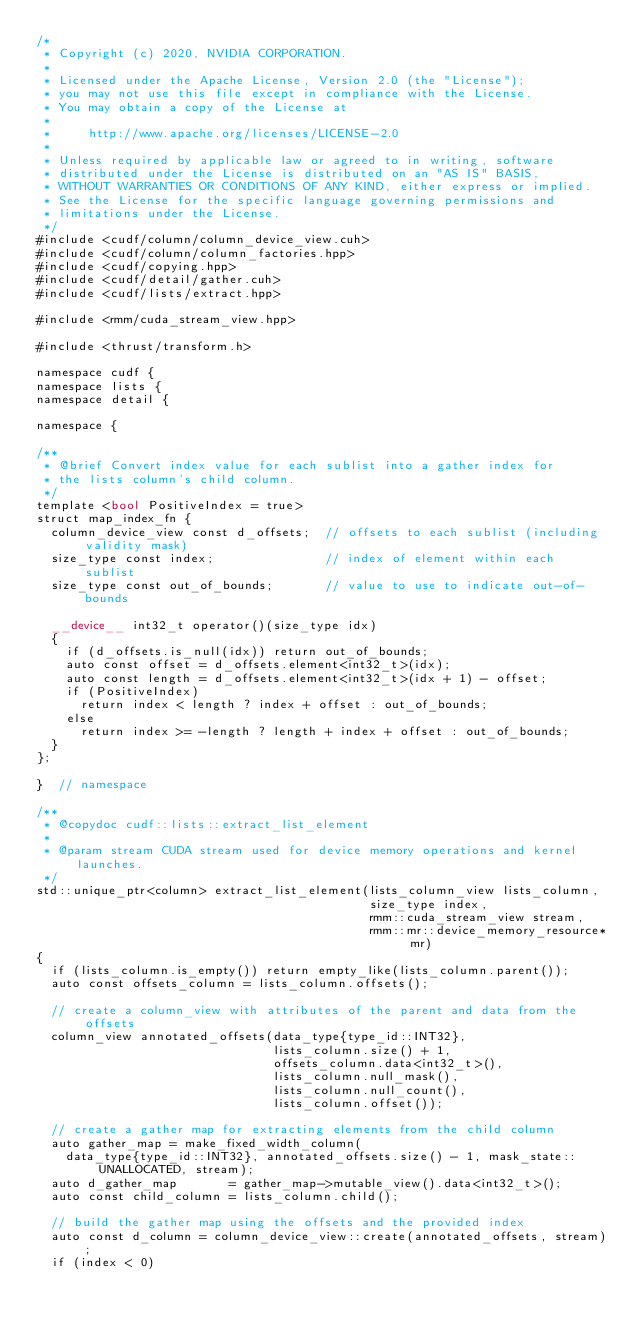<code> <loc_0><loc_0><loc_500><loc_500><_Cuda_>/*
 * Copyright (c) 2020, NVIDIA CORPORATION.
 *
 * Licensed under the Apache License, Version 2.0 (the "License");
 * you may not use this file except in compliance with the License.
 * You may obtain a copy of the License at
 *
 *     http://www.apache.org/licenses/LICENSE-2.0
 *
 * Unless required by applicable law or agreed to in writing, software
 * distributed under the License is distributed on an "AS IS" BASIS,
 * WITHOUT WARRANTIES OR CONDITIONS OF ANY KIND, either express or implied.
 * See the License for the specific language governing permissions and
 * limitations under the License.
 */
#include <cudf/column/column_device_view.cuh>
#include <cudf/column/column_factories.hpp>
#include <cudf/copying.hpp>
#include <cudf/detail/gather.cuh>
#include <cudf/lists/extract.hpp>

#include <rmm/cuda_stream_view.hpp>

#include <thrust/transform.h>

namespace cudf {
namespace lists {
namespace detail {

namespace {

/**
 * @brief Convert index value for each sublist into a gather index for
 * the lists column's child column.
 */
template <bool PositiveIndex = true>
struct map_index_fn {
  column_device_view const d_offsets;  // offsets to each sublist (including validity mask)
  size_type const index;               // index of element within each sublist
  size_type const out_of_bounds;       // value to use to indicate out-of-bounds

  __device__ int32_t operator()(size_type idx)
  {
    if (d_offsets.is_null(idx)) return out_of_bounds;
    auto const offset = d_offsets.element<int32_t>(idx);
    auto const length = d_offsets.element<int32_t>(idx + 1) - offset;
    if (PositiveIndex)
      return index < length ? index + offset : out_of_bounds;
    else
      return index >= -length ? length + index + offset : out_of_bounds;
  }
};

}  // namespace

/**
 * @copydoc cudf::lists::extract_list_element
 *
 * @param stream CUDA stream used for device memory operations and kernel launches.
 */
std::unique_ptr<column> extract_list_element(lists_column_view lists_column,
                                             size_type index,
                                             rmm::cuda_stream_view stream,
                                             rmm::mr::device_memory_resource* mr)
{
  if (lists_column.is_empty()) return empty_like(lists_column.parent());
  auto const offsets_column = lists_column.offsets();

  // create a column_view with attributes of the parent and data from the offsets
  column_view annotated_offsets(data_type{type_id::INT32},
                                lists_column.size() + 1,
                                offsets_column.data<int32_t>(),
                                lists_column.null_mask(),
                                lists_column.null_count(),
                                lists_column.offset());

  // create a gather map for extracting elements from the child column
  auto gather_map = make_fixed_width_column(
    data_type{type_id::INT32}, annotated_offsets.size() - 1, mask_state::UNALLOCATED, stream);
  auto d_gather_map       = gather_map->mutable_view().data<int32_t>();
  auto const child_column = lists_column.child();

  // build the gather map using the offsets and the provided index
  auto const d_column = column_device_view::create(annotated_offsets, stream);
  if (index < 0)</code> 